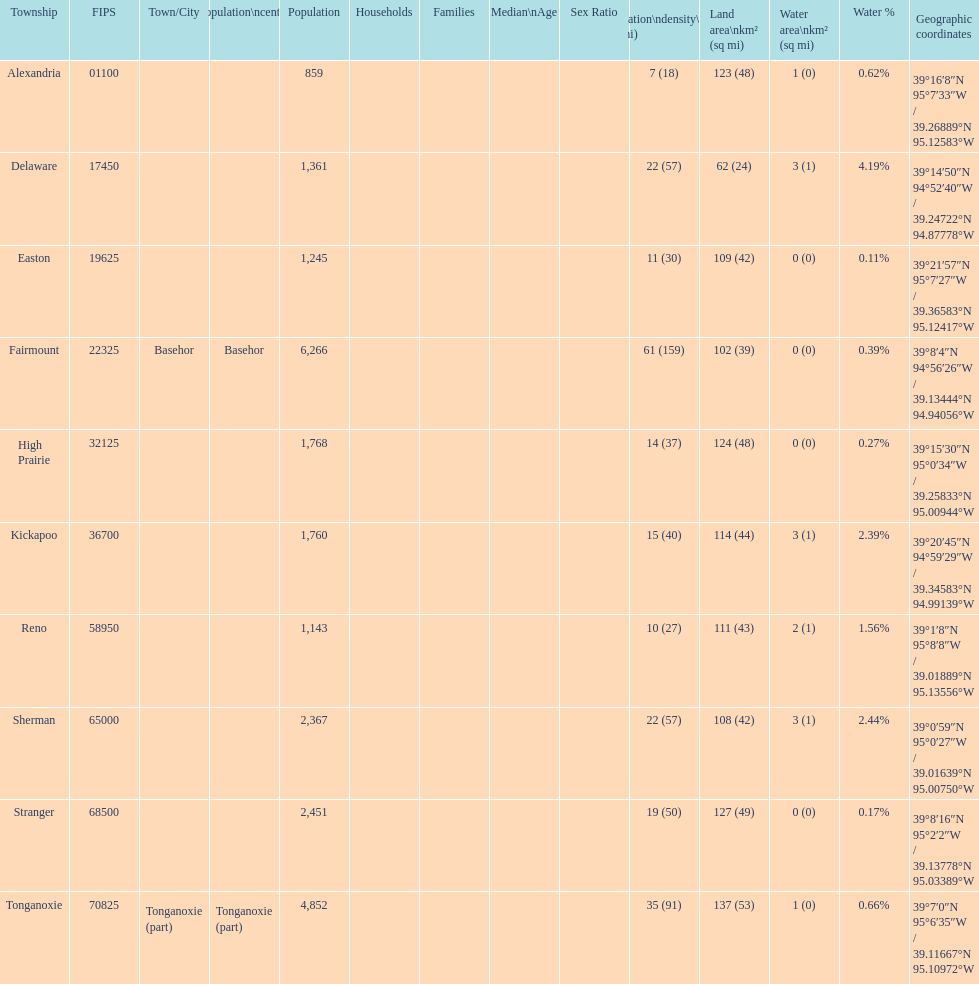How many townships are in leavenworth county? 10. 